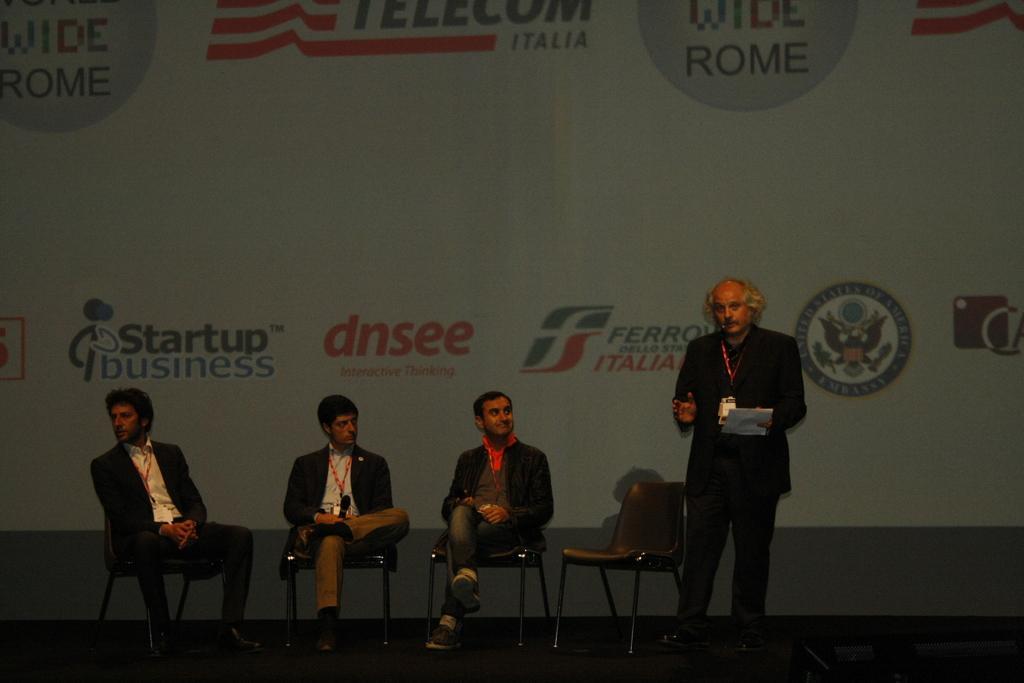Please provide a concise description of this image. In this image there are three persons who are sitting on the chairs. On the right side there is a man who is standing on the floor by holding the paper. In the background there is a hoarding. 